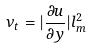Convert formula to latex. <formula><loc_0><loc_0><loc_500><loc_500>\nu _ { t } = | \frac { \partial u } { \partial y } | l _ { m } ^ { 2 }</formula> 